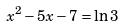Convert formula to latex. <formula><loc_0><loc_0><loc_500><loc_500>x ^ { 2 } - 5 x - 7 = \ln 3</formula> 